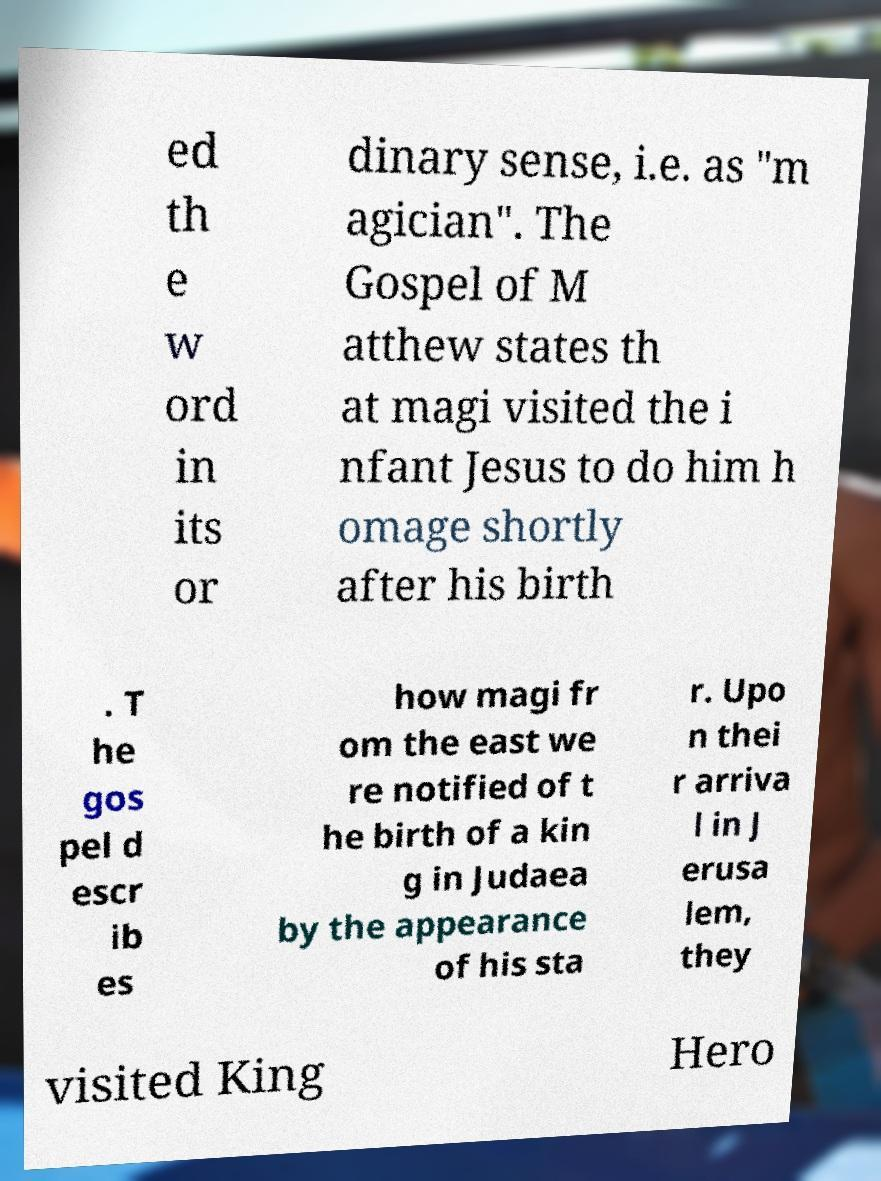Could you assist in decoding the text presented in this image and type it out clearly? ed th e w ord in its or dinary sense, i.e. as "m agician". The Gospel of M atthew states th at magi visited the i nfant Jesus to do him h omage shortly after his birth . T he gos pel d escr ib es how magi fr om the east we re notified of t he birth of a kin g in Judaea by the appearance of his sta r. Upo n thei r arriva l in J erusa lem, they visited King Hero 